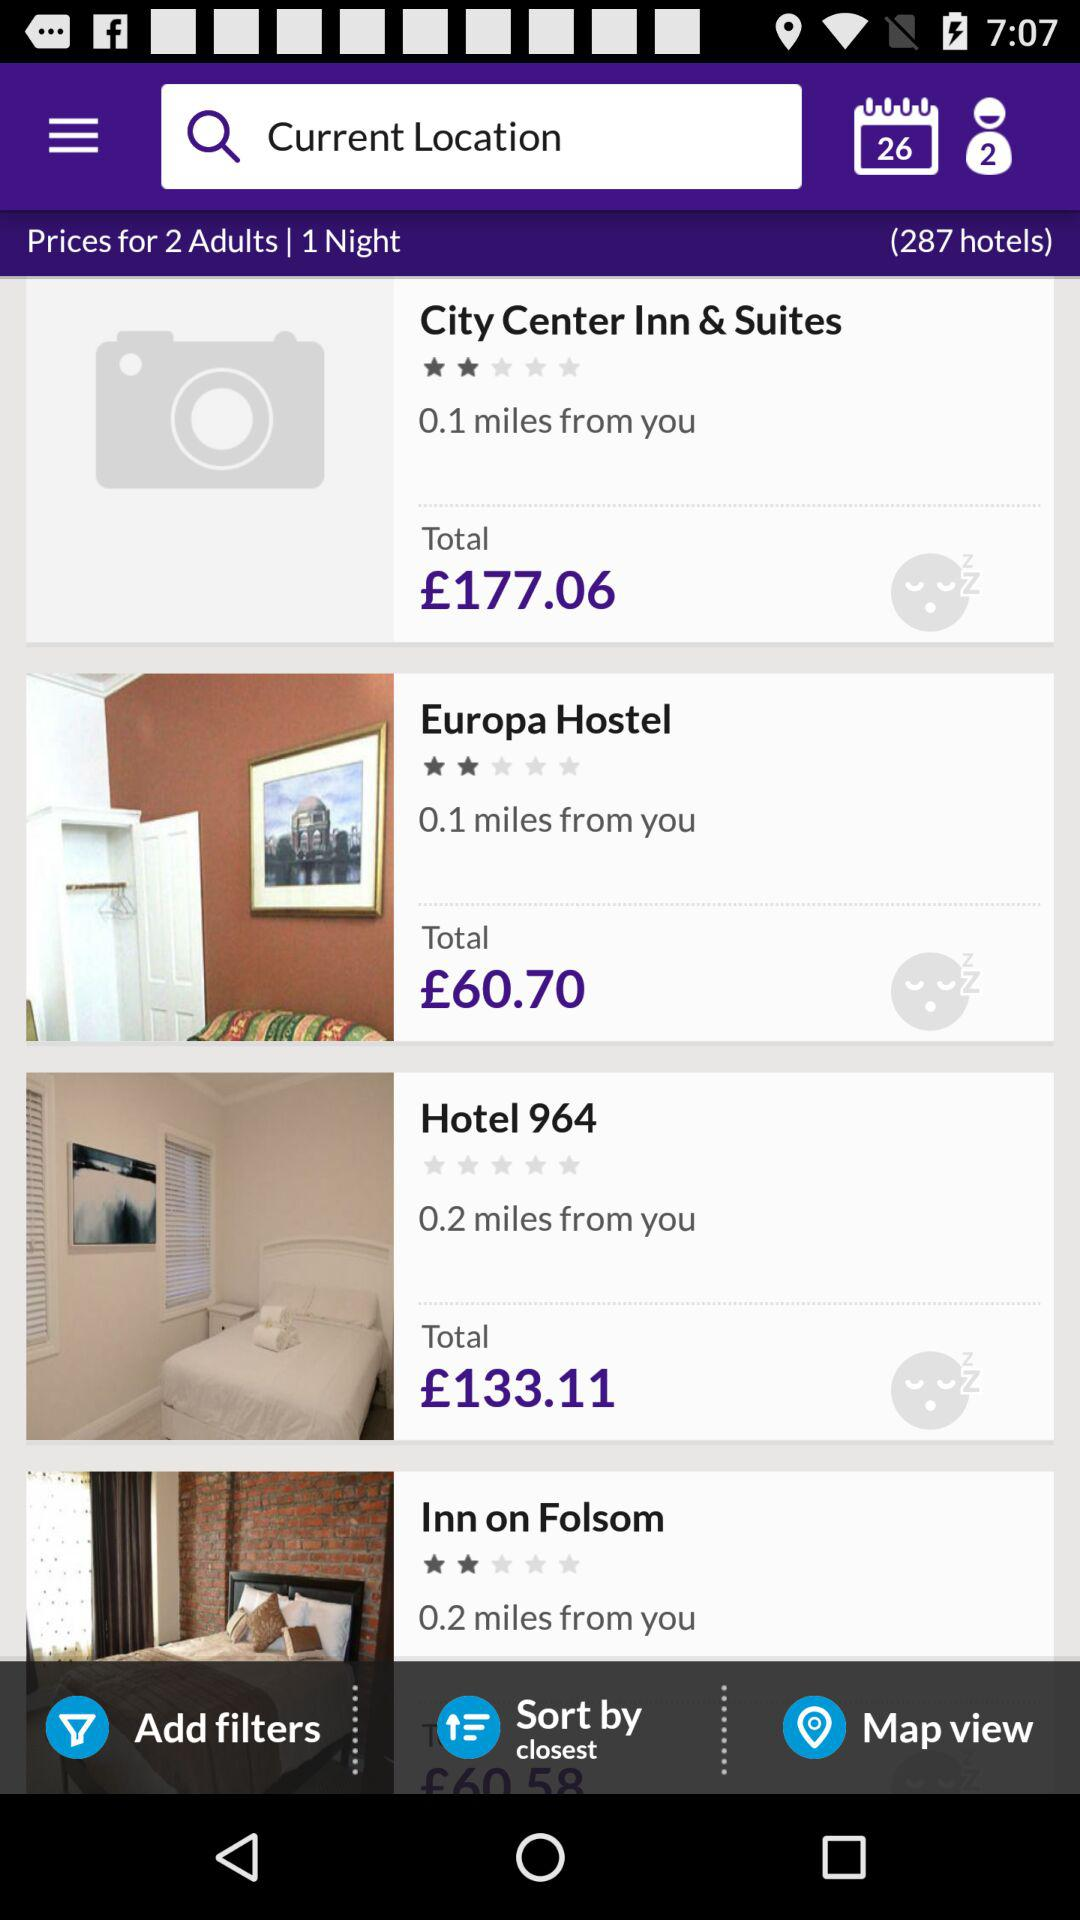How many hotels are there?
Answer the question using a single word or phrase. 287 